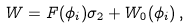<formula> <loc_0><loc_0><loc_500><loc_500>W = F ( \phi _ { i } ) \sigma _ { 2 } + W _ { 0 } ( \phi _ { i } ) \, ,</formula> 